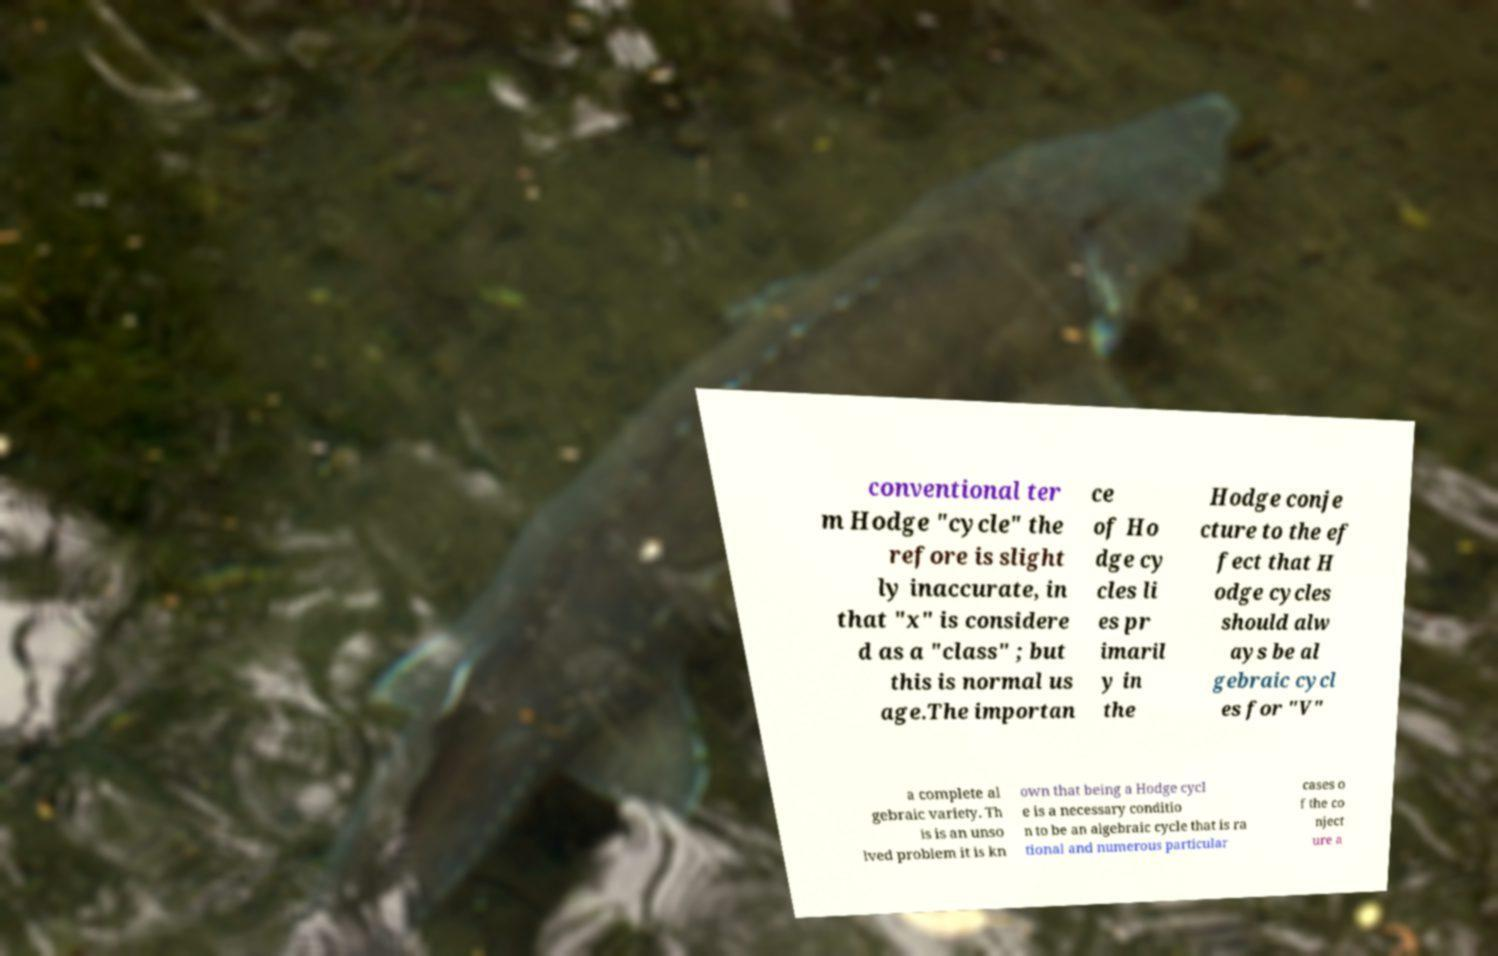For documentation purposes, I need the text within this image transcribed. Could you provide that? conventional ter m Hodge "cycle" the refore is slight ly inaccurate, in that "x" is considere d as a "class" ; but this is normal us age.The importan ce of Ho dge cy cles li es pr imaril y in the Hodge conje cture to the ef fect that H odge cycles should alw ays be al gebraic cycl es for "V" a complete al gebraic variety. Th is is an unso lved problem it is kn own that being a Hodge cycl e is a necessary conditio n to be an algebraic cycle that is ra tional and numerous particular cases o f the co nject ure a 